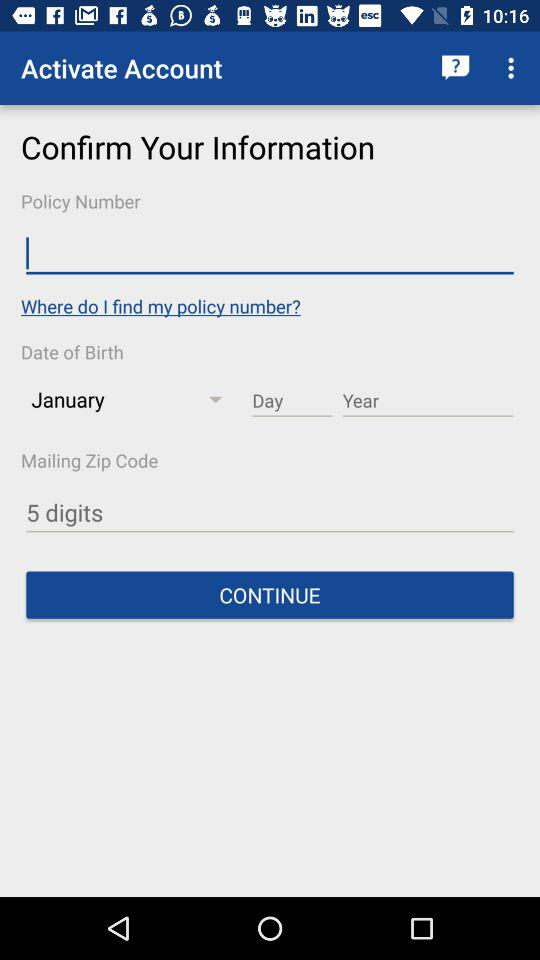How many digits are required for the mailing zip code? The required number of digits is 5. 